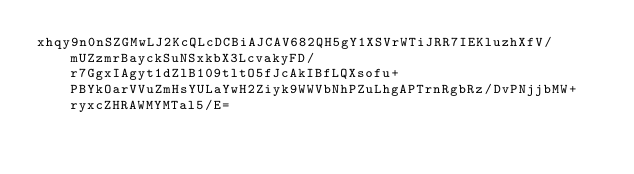Convert code to text. <code><loc_0><loc_0><loc_500><loc_500><_SML_>xhqy9n0nSZGMwLJ2KcQLcDCBiAJCAV682QH5gY1XSVrWTiJRR7IEKluzhXfV/mUZzmrBayckSuNSxkbX3LcvakyFD/r7GgxIAgyt1dZlB109tltO5fJcAkIBfLQXsofu+PBYkOarVVuZmHsYULaYwH2Ziyk9WWVbNhPZuLhgAPTrnRgbRz/DvPNjjbMW+ryxcZHRAWMYMTal5/E=</code> 